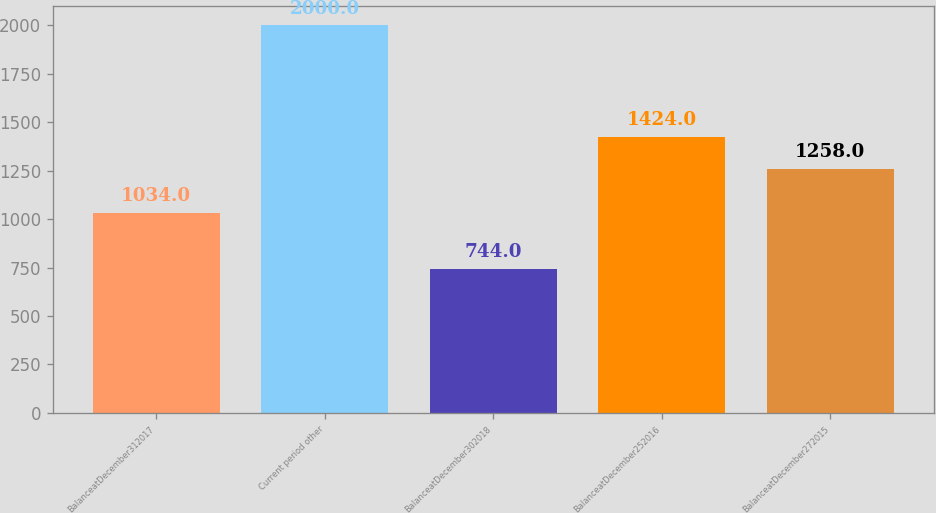<chart> <loc_0><loc_0><loc_500><loc_500><bar_chart><fcel>BalanceatDecember312017<fcel>Current period other<fcel>BalanceatDecember302018<fcel>BalanceatDecember252016<fcel>BalanceatDecember272015<nl><fcel>1034<fcel>2000<fcel>744<fcel>1424<fcel>1258<nl></chart> 